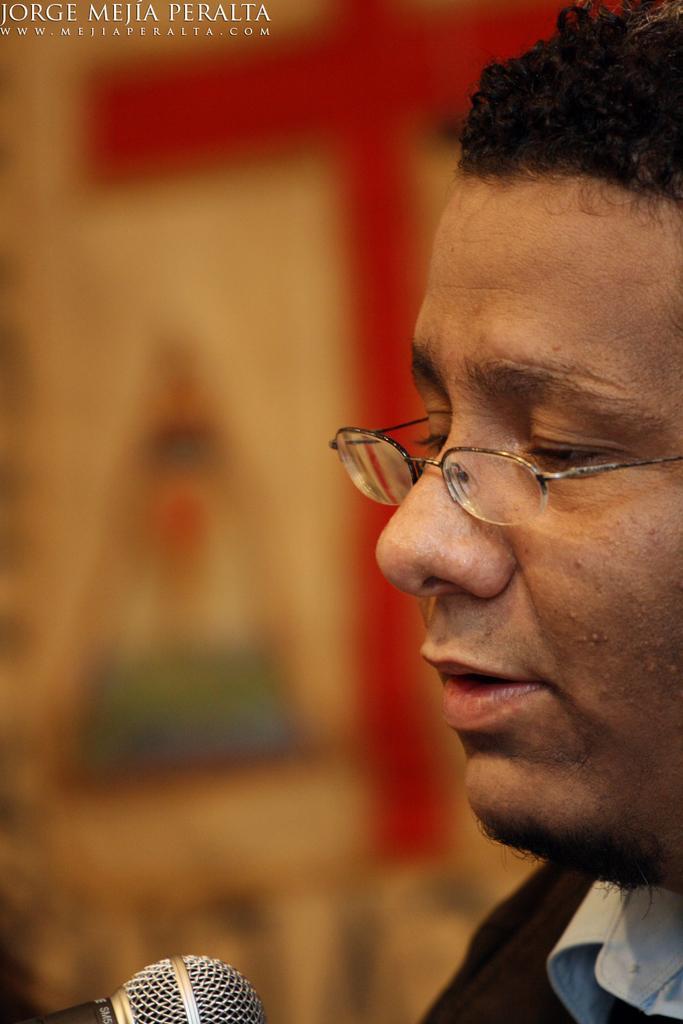Please provide a concise description of this image. In the foreground of this image, on the right, there is a face of a man and in front of him, there is a mic and the background image is blur. 